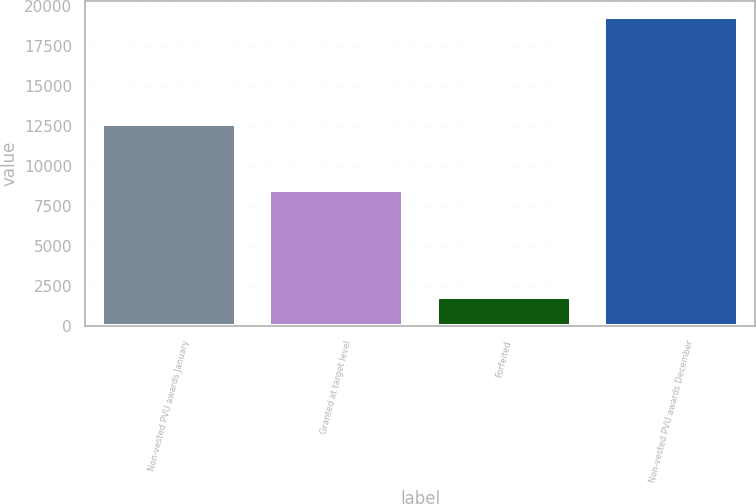Convert chart. <chart><loc_0><loc_0><loc_500><loc_500><bar_chart><fcel>Non-vested PVU awards January<fcel>Granted at target level<fcel>Forfeited<fcel>Non-vested PVU awards December<nl><fcel>12632<fcel>8523<fcel>1809<fcel>19346<nl></chart> 